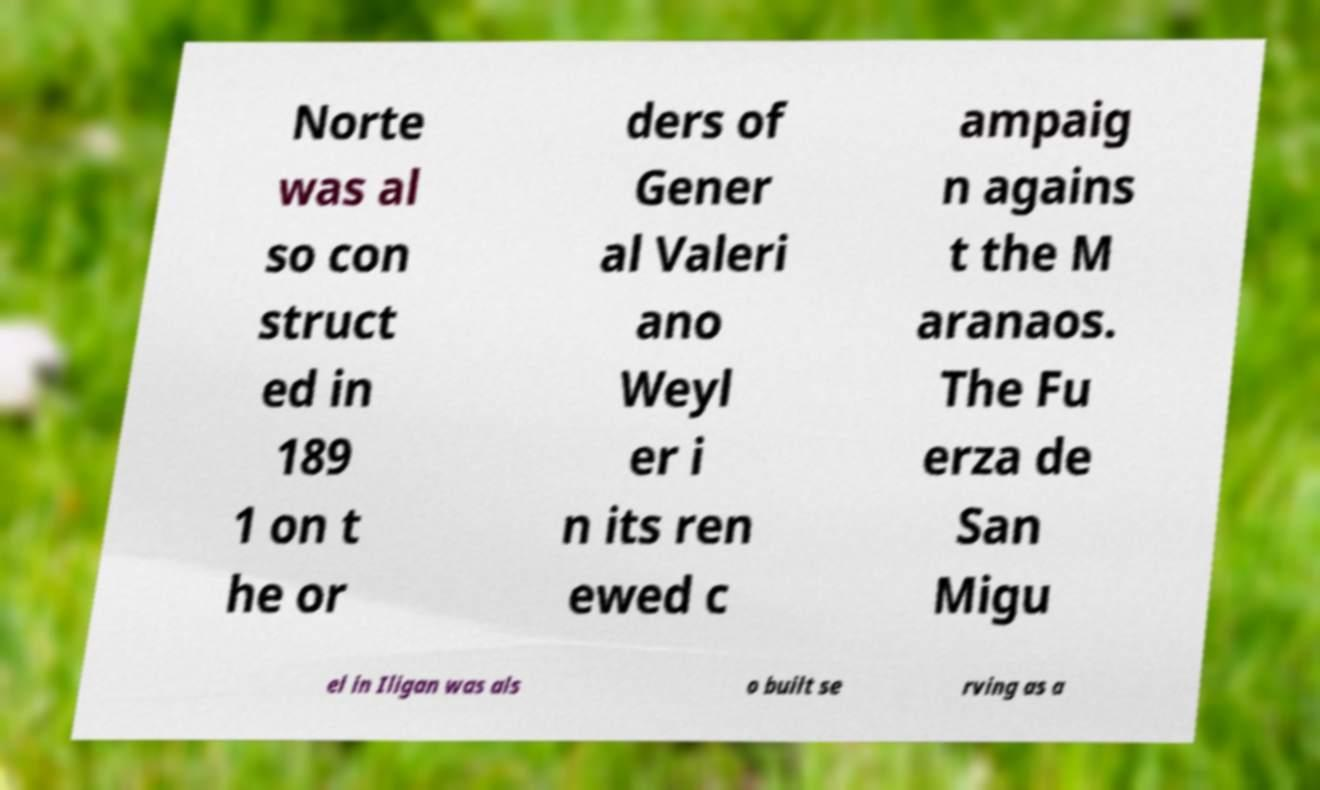What messages or text are displayed in this image? I need them in a readable, typed format. Norte was al so con struct ed in 189 1 on t he or ders of Gener al Valeri ano Weyl er i n its ren ewed c ampaig n agains t the M aranaos. The Fu erza de San Migu el in Iligan was als o built se rving as a 